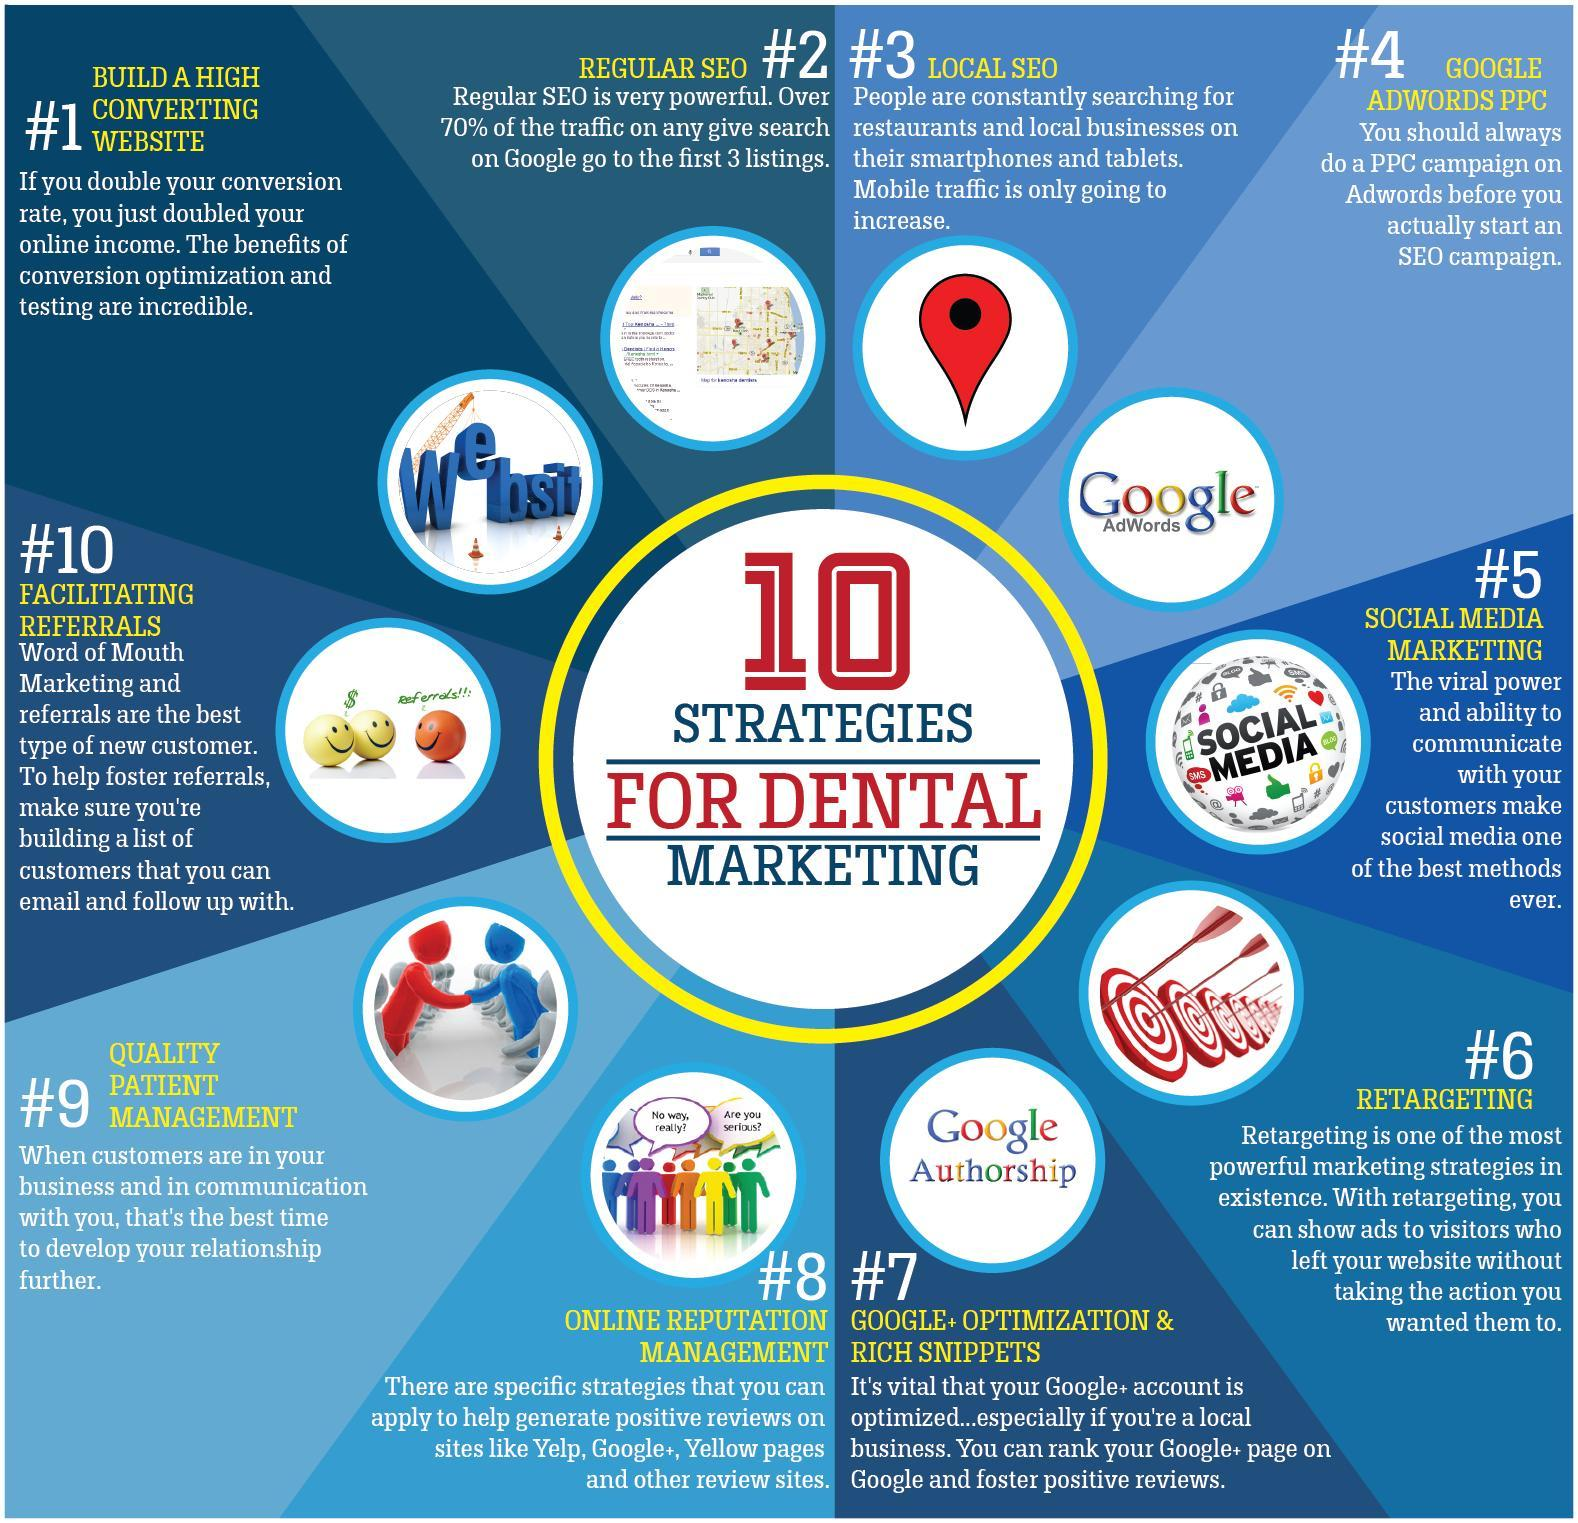what is the 8th point
Answer the question with a short phrase. Online reputation management what are the 2 questions written in the image representing point 8 No way, really?, Are you serious? What is the 10th point Facilitating referrals What needs to be done before starting an SEO campaign Always do a PPC campaign on Adwords What is written above the orange smiley referrals!!: 